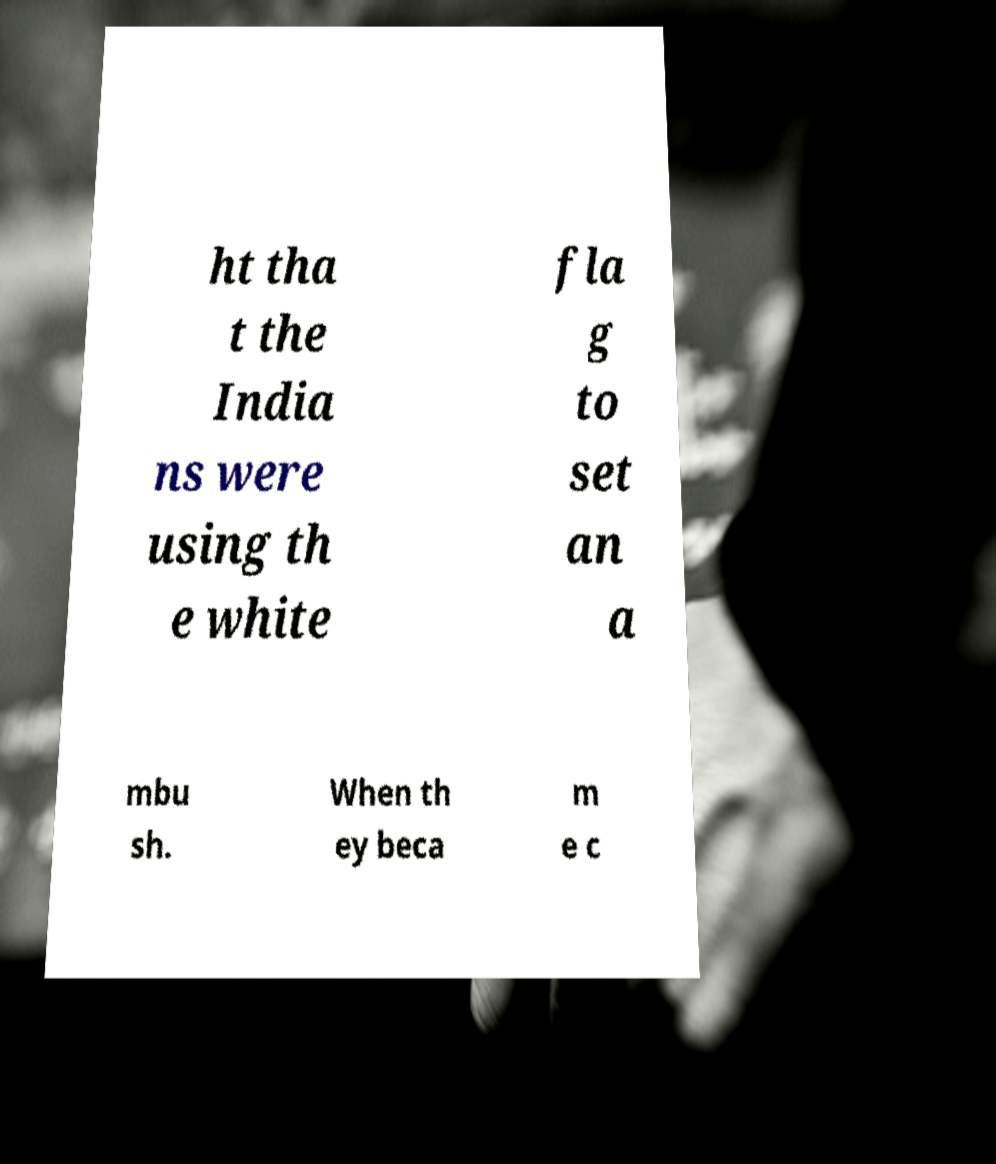I need the written content from this picture converted into text. Can you do that? ht tha t the India ns were using th e white fla g to set an a mbu sh. When th ey beca m e c 